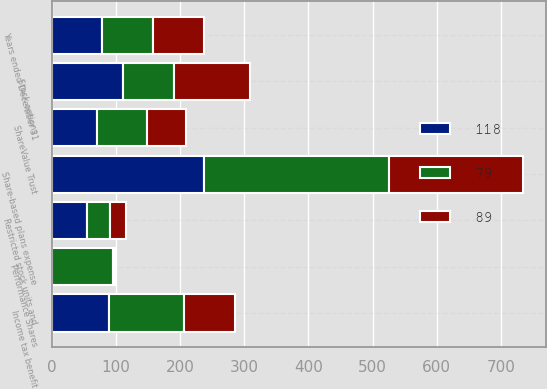<chart> <loc_0><loc_0><loc_500><loc_500><stacked_bar_chart><ecel><fcel>Years ended December 31<fcel>Stock options<fcel>Restricted stock units and<fcel>ShareValue Trust<fcel>Performance Shares<fcel>Share-based plans expense<fcel>Income tax benefit<nl><fcel>118<fcel>79<fcel>111<fcel>55<fcel>71<fcel>1<fcel>238<fcel>89<nl><fcel>89<fcel>79<fcel>119<fcel>25<fcel>61<fcel>4<fcel>209<fcel>79<nl><fcel>79<fcel>79<fcel>79<fcel>36<fcel>78<fcel>94<fcel>287<fcel>118<nl></chart> 